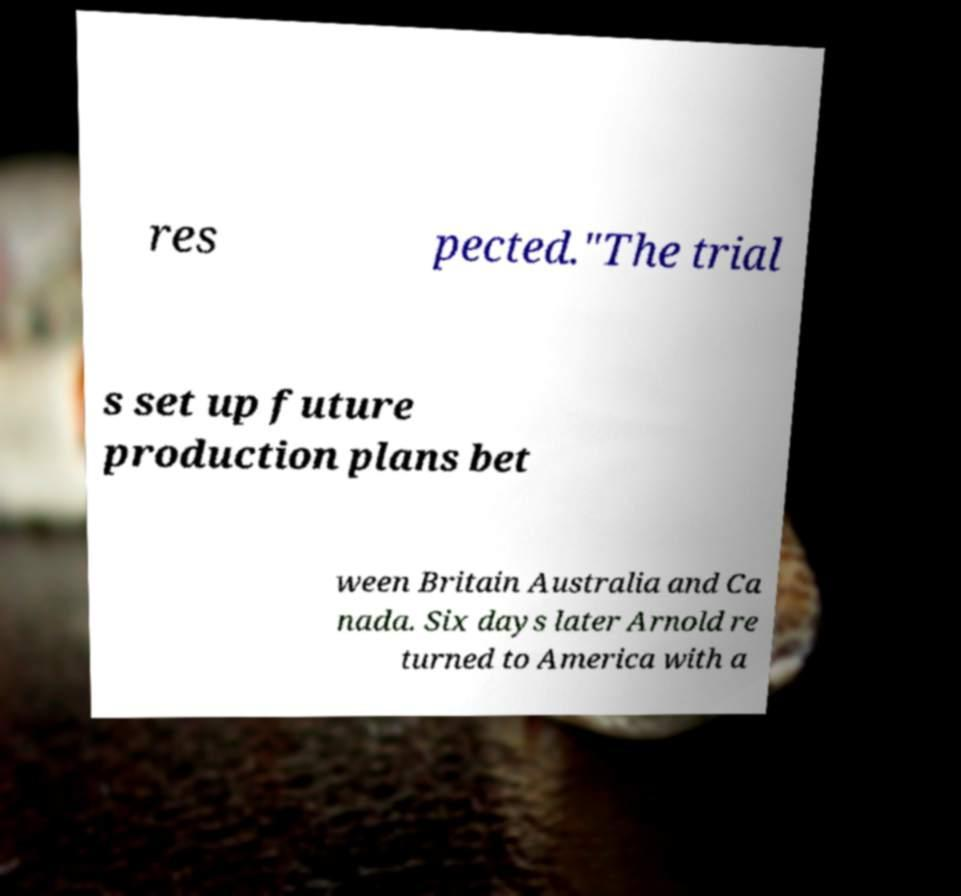I need the written content from this picture converted into text. Can you do that? res pected."The trial s set up future production plans bet ween Britain Australia and Ca nada. Six days later Arnold re turned to America with a 